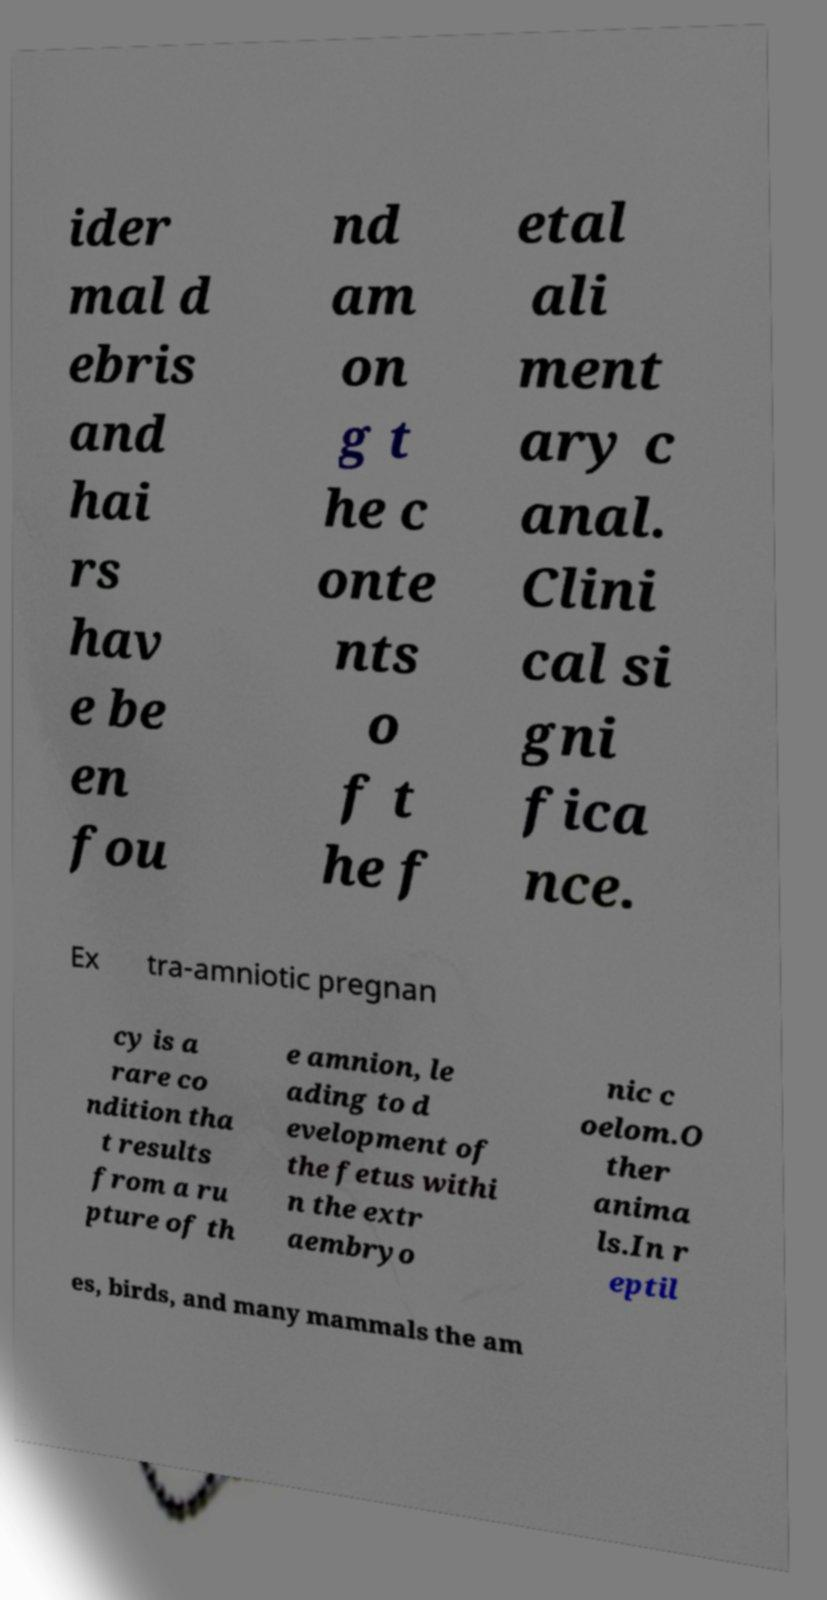Can you read and provide the text displayed in the image?This photo seems to have some interesting text. Can you extract and type it out for me? ider mal d ebris and hai rs hav e be en fou nd am on g t he c onte nts o f t he f etal ali ment ary c anal. Clini cal si gni fica nce. Ex tra-amniotic pregnan cy is a rare co ndition tha t results from a ru pture of th e amnion, le ading to d evelopment of the fetus withi n the extr aembryo nic c oelom.O ther anima ls.In r eptil es, birds, and many mammals the am 